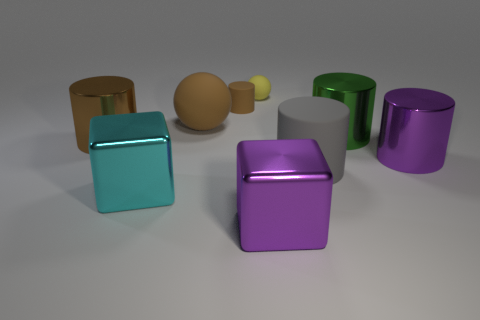There is a purple metallic object that is on the left side of the big green thing; what is its shape?
Make the answer very short. Cube. There is a shiny thing to the left of the large cyan metallic thing; does it have the same color as the rubber sphere in front of the yellow matte thing?
Your response must be concise. Yes. What number of things are right of the large green metallic object and behind the brown ball?
Ensure brevity in your answer.  0. What size is the brown cylinder that is the same material as the small yellow ball?
Give a very brief answer. Small. How big is the yellow sphere?
Provide a succinct answer. Small. What is the material of the tiny sphere?
Your answer should be compact. Rubber. Do the object that is to the left of the cyan metal thing and the green metal cylinder have the same size?
Provide a short and direct response. Yes. How many objects are small red things or brown objects?
Offer a terse response. 3. The matte object that is the same color as the large matte sphere is what shape?
Your response must be concise. Cylinder. There is a rubber thing that is right of the brown matte cylinder and behind the green cylinder; what size is it?
Make the answer very short. Small. 